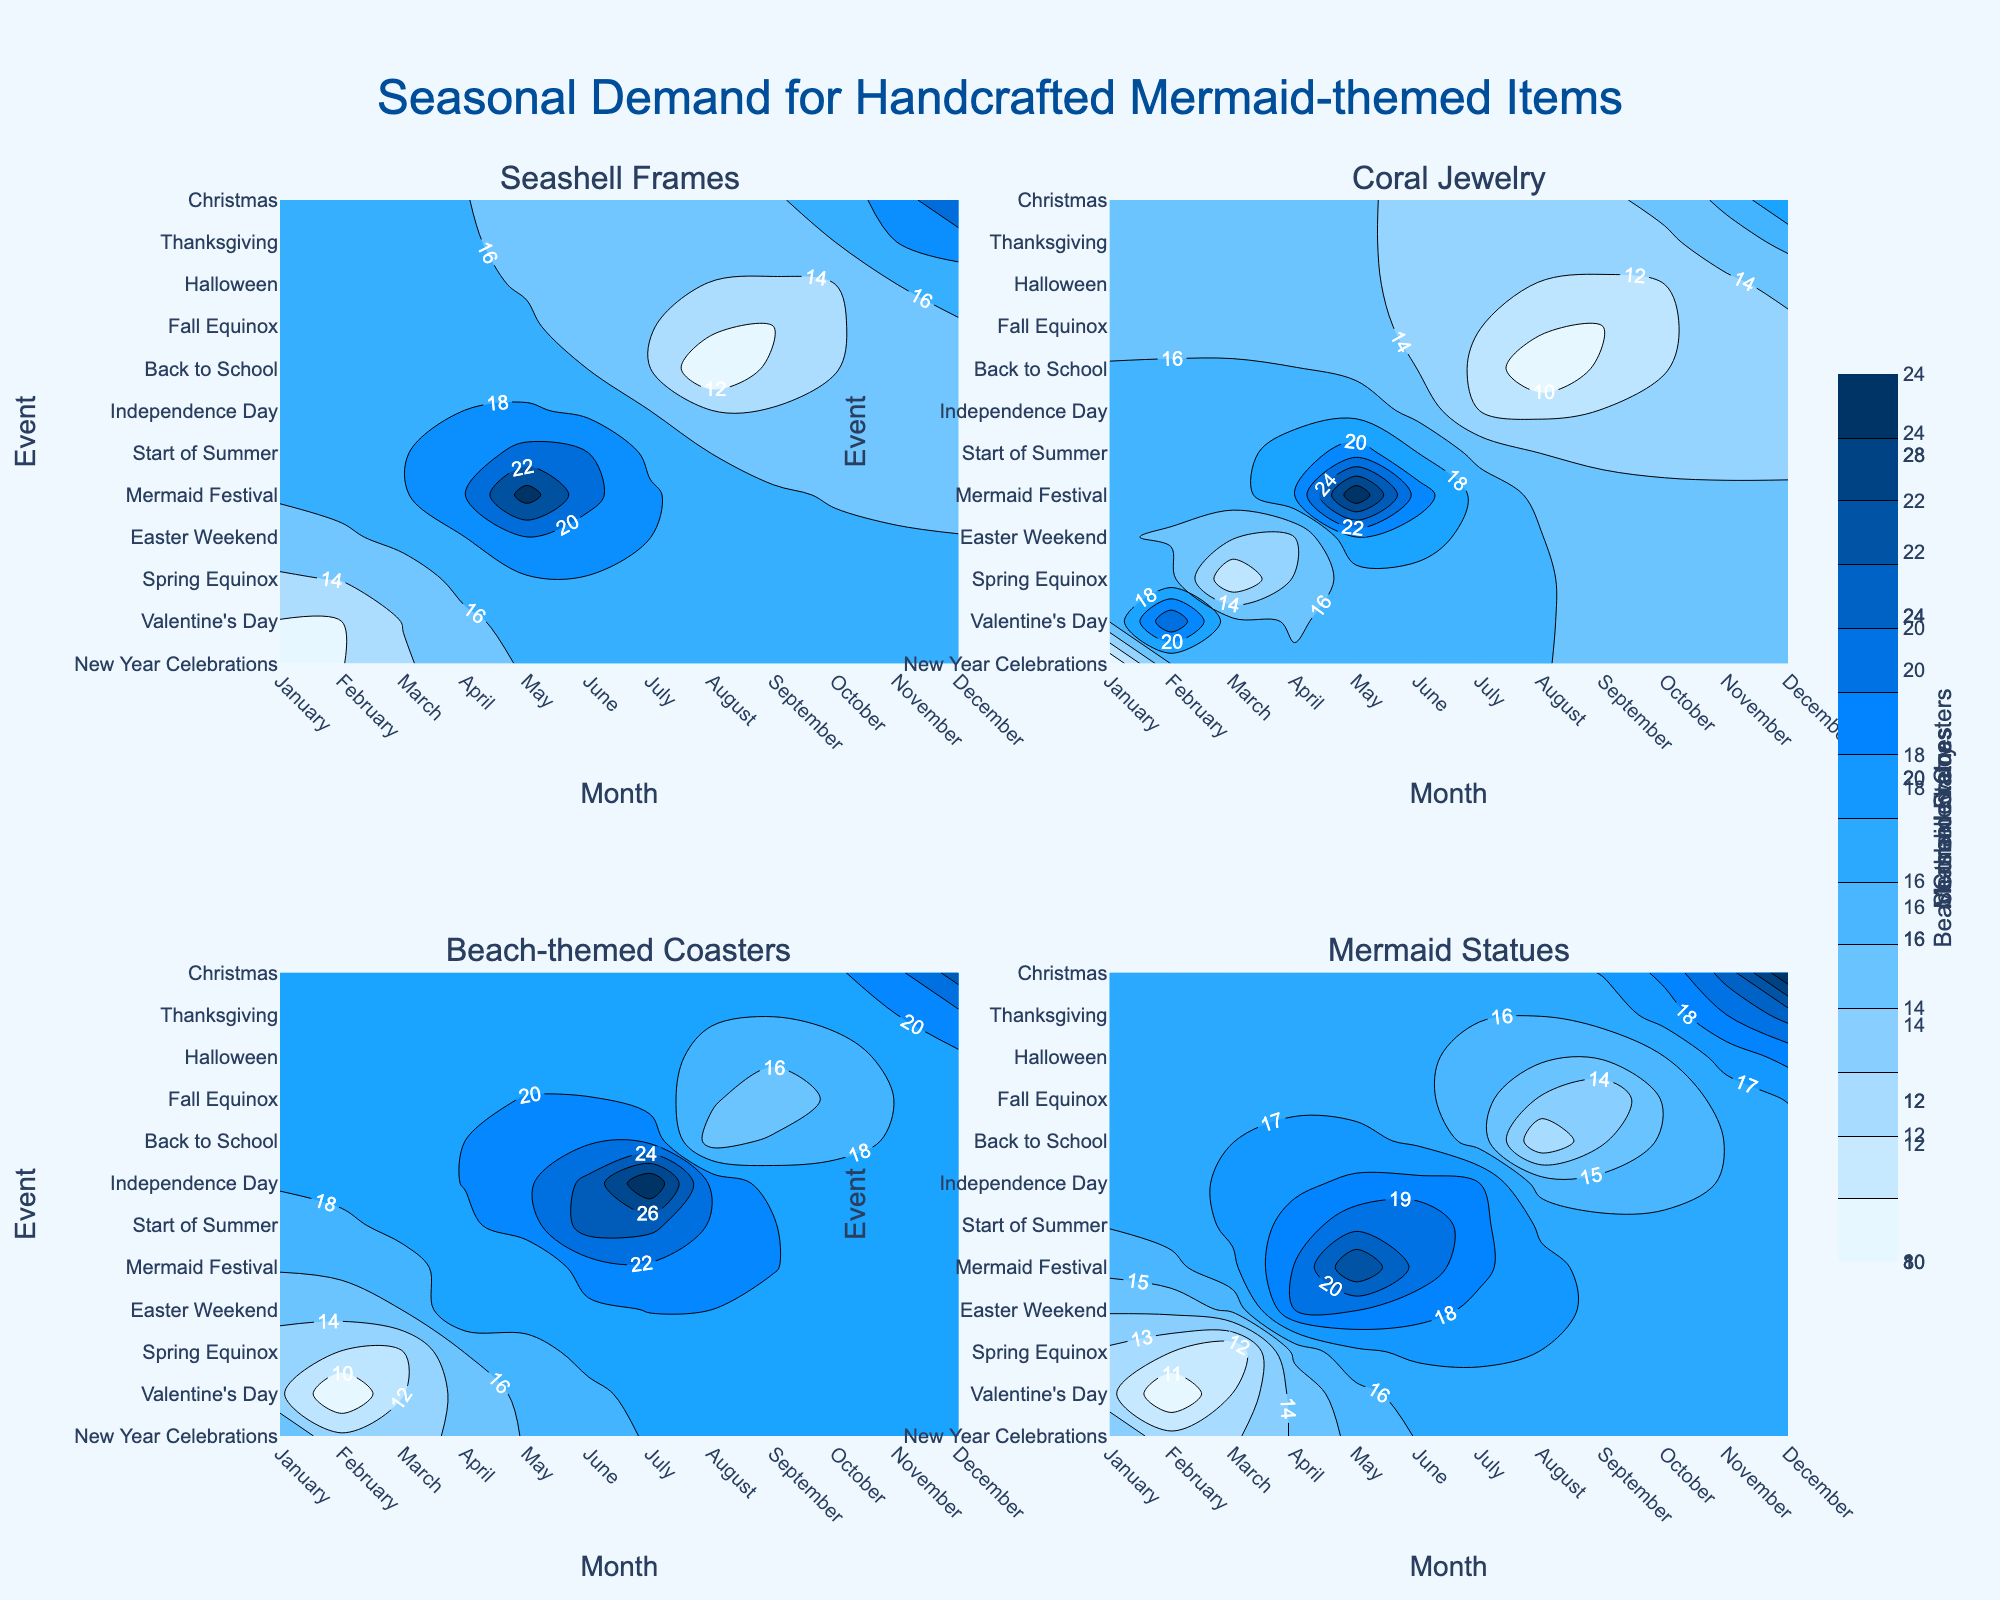What is the title of the figure? The title is prominently displayed at the top center of the figure in larger font size and a specific color to draw attention.
Answer: Seasonal Demand for Handcrafted Mermaid-themed Items What colors are used in the contour plots? The colors range from light blue to dark blue, indicating varying levels of demand. The color scheme helps in visualizing the density of the data points.
Answer: Light to dark blue Which handcrafted item has the highest demand in December? By observing the contour plot for each item for the month of December, you can see that Mermaid Statues have the highest intensity color, indicating the highest demand.
Answer: Mermaid Statues How does the demand for Coral Jewelry in February compare to April? Looking at the contour plots for Coral Jewelry, the color intensity is higher in February compared to April, indicating a higher demand in February.
Answer: Higher in February What is the average demand for Seashell Frames in July and August? In July, the demand is 16, and in August, it is 10. Adding these (16 + 10) gives 26, and the average is 26 / 2 = 13.
Answer: 13 Which event sees the highest demand for Beach-themed Coasters? The contour plot for Beach-themed Coasters indicates the highest color intensity during Independence Day in July, indicating the highest demand.
Answer: Independence Day What are the events associated with the highest demand for each handcrafted item in May? For Seashell Frames and Mermaid Statues, the highest demand in May is during the Mermaid Festival. The contour for Coral Jewelry shows the highest demand during the same event. Hence, Mermaid Festival is the event with the highest demand for all items in May.
Answer: Mermaid Festival Compare the demand for Mermaid Statues during Valentine's Day and Thanksgiving. By observing the contour plot, the color intensity for Mermaid Statues during Valentine's Day is lower than that during Thanksgiving, indicating lower demand in February compared to November.
Answer: Higher in November In which month does the demand for handcrafted items overall peak? By observing the contour intensities for all items, December shows the highest intensity across all items, indicating the overall peak in demand for handcrafted items.
Answer: December 